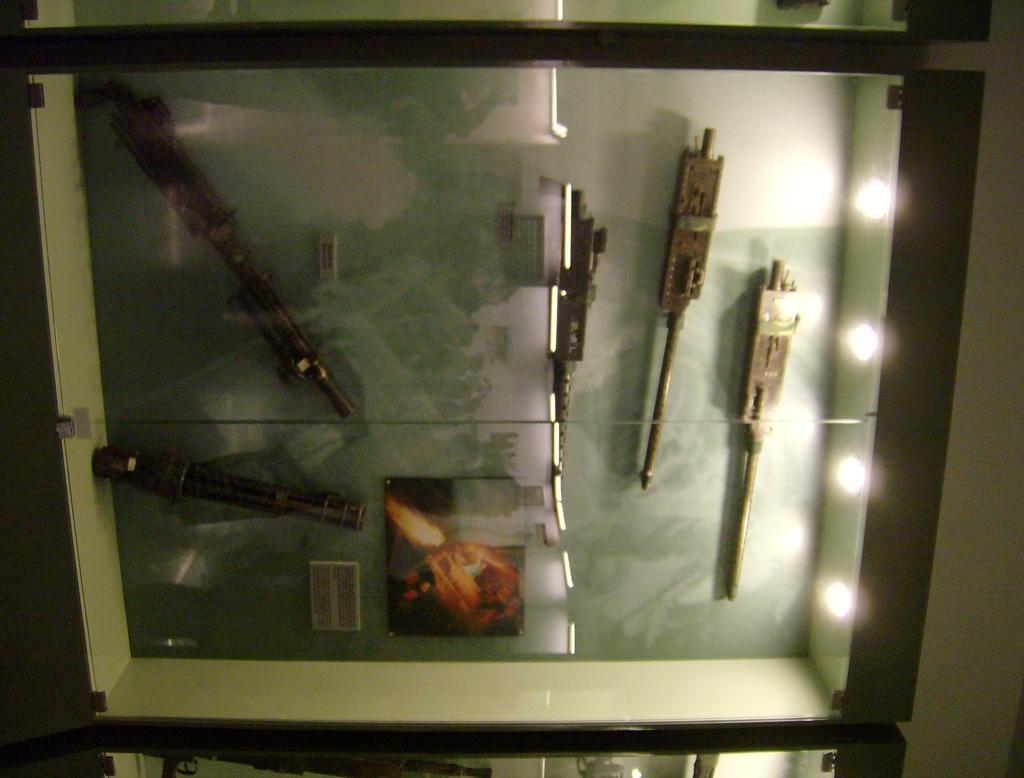Could you give a brief overview of what you see in this image? In this picture there is a wooden box. In which we can see some equipment which is made from the rod. On the right we can see the lights, beside that we can see the wall. 